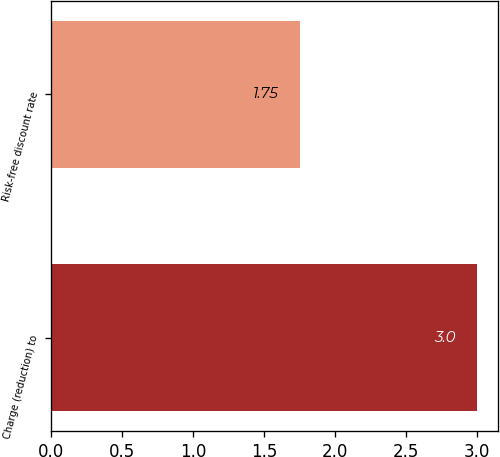Convert chart to OTSL. <chart><loc_0><loc_0><loc_500><loc_500><bar_chart><fcel>Charge (reduction) to<fcel>Risk-free discount rate<nl><fcel>3<fcel>1.75<nl></chart> 